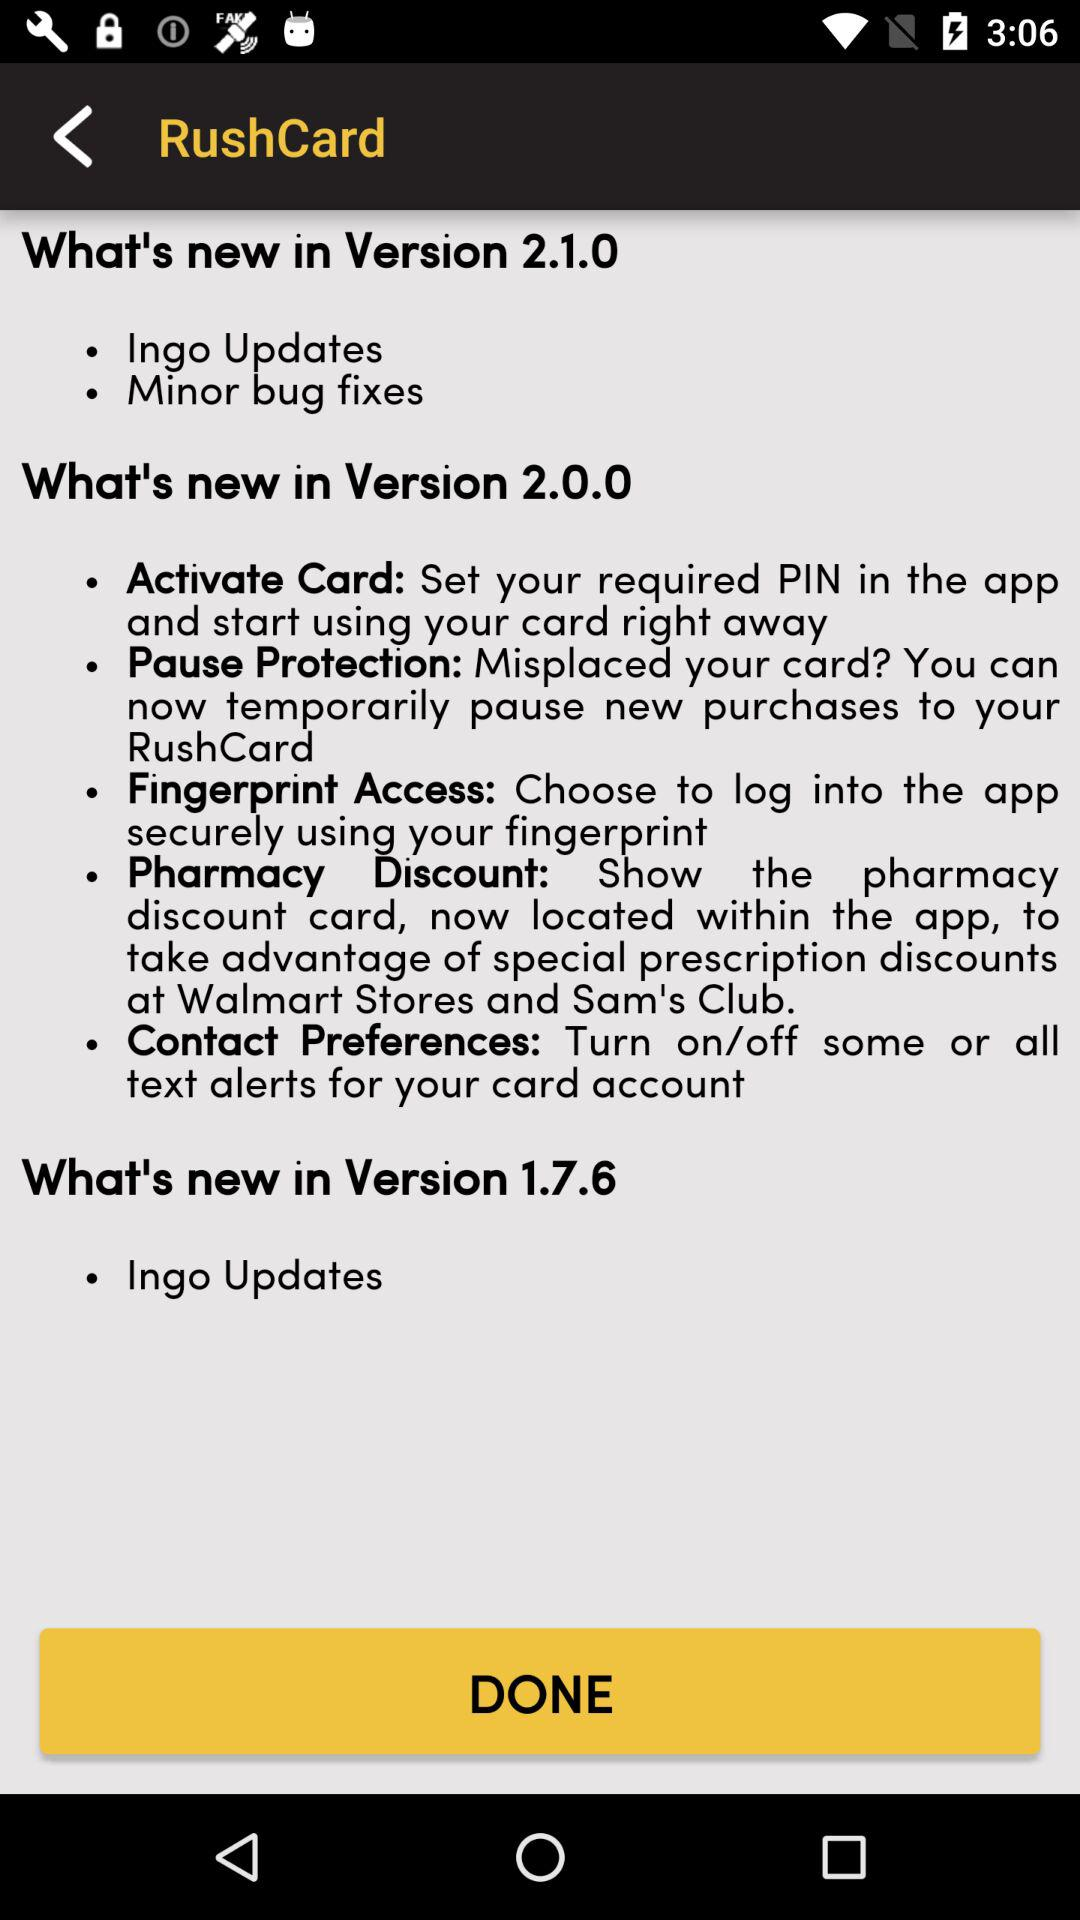How many versions of the app have been released?
Answer the question using a single word or phrase. 3 